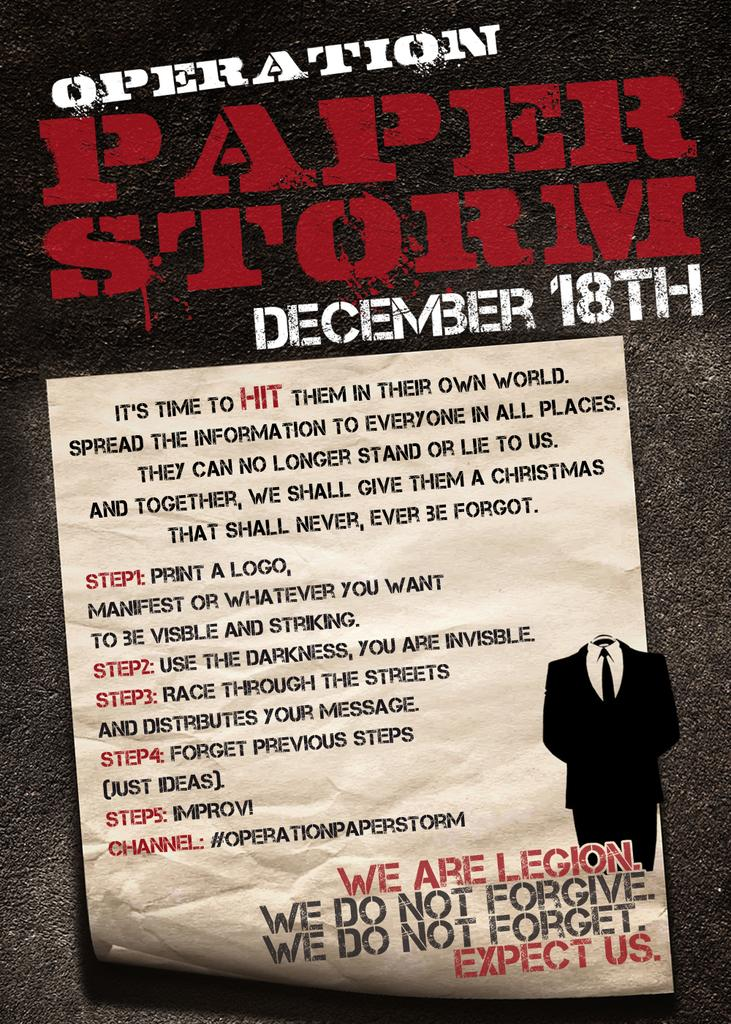What is the main subject of the image? The main subject of the image is text written on a white color paper. Can you describe the size difference between the text at the top and bottom of the image? Yes, the text at the top of the image is written in a big format, while the text at the bottom is written in a smaller format. What is the smell of the ocean like in the image? There is no ocean present in the image, so it is not possible to determine the smell of the ocean. 